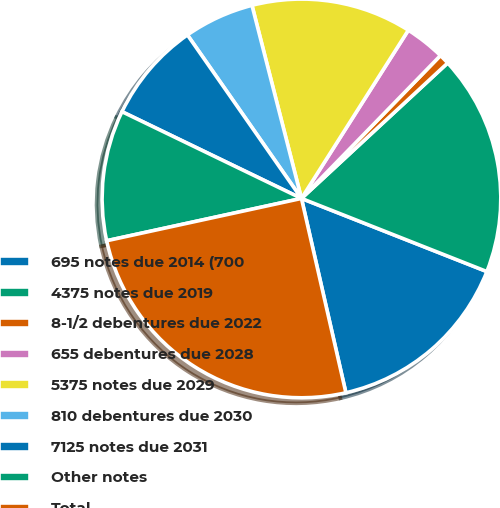<chart> <loc_0><loc_0><loc_500><loc_500><pie_chart><fcel>695 notes due 2014 (700<fcel>4375 notes due 2019<fcel>8-1/2 debentures due 2022<fcel>655 debentures due 2028<fcel>5375 notes due 2029<fcel>810 debentures due 2030<fcel>7125 notes due 2031<fcel>Other notes<fcel>Total<nl><fcel>15.44%<fcel>17.87%<fcel>0.83%<fcel>3.27%<fcel>13.0%<fcel>5.7%<fcel>8.14%<fcel>10.57%<fcel>25.17%<nl></chart> 